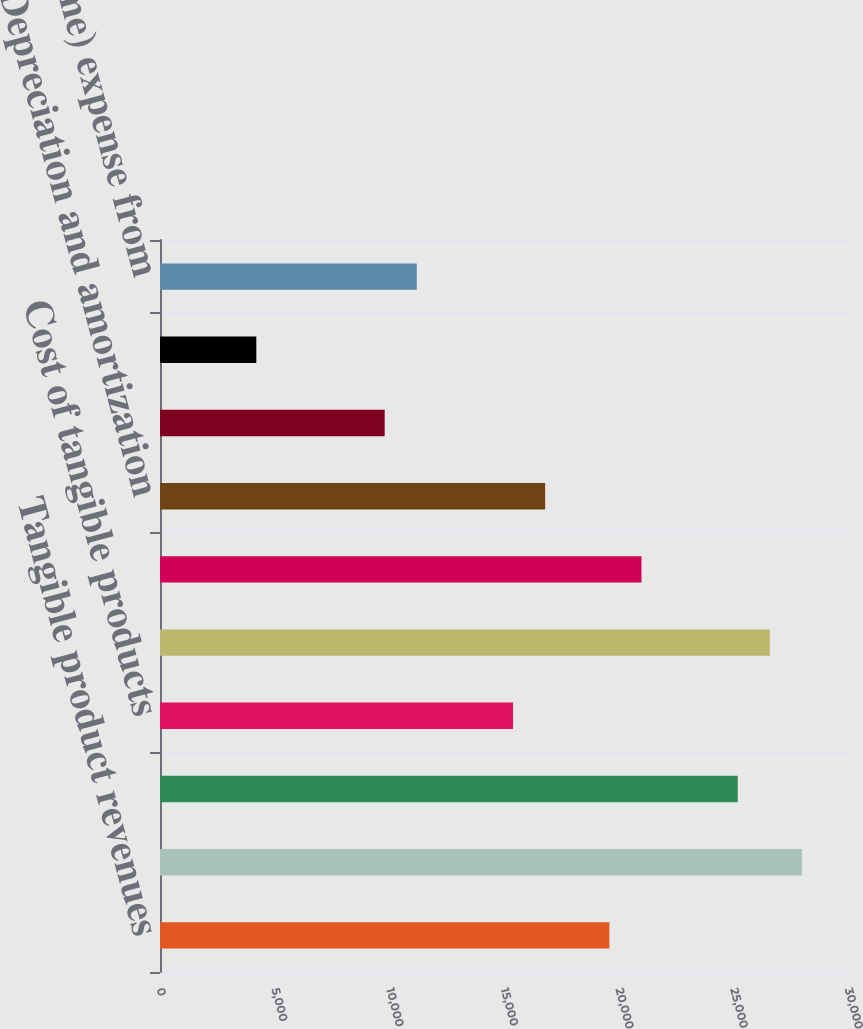Convert chart. <chart><loc_0><loc_0><loc_500><loc_500><bar_chart><fcel>Tangible product revenues<fcel>Total operating revenues<fcel>Cost of services<fcel>Cost of tangible products<fcel>Total operating costs<fcel>Selling general and<fcel>Depreciation and amortization<fcel>Restructuring<fcel>Goodwill impairments<fcel>(Income) expense from<nl><fcel>19593.8<fcel>27990.5<fcel>25191.6<fcel>15395.5<fcel>26591<fcel>20993.2<fcel>16794.9<fcel>9797.65<fcel>4199.85<fcel>11197.1<nl></chart> 